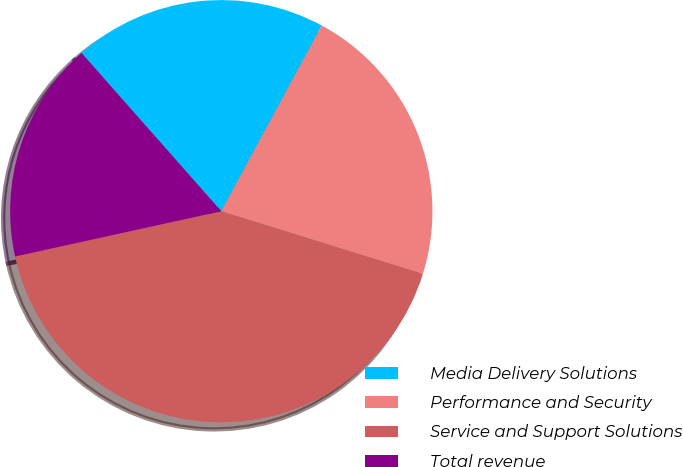Convert chart to OTSL. <chart><loc_0><loc_0><loc_500><loc_500><pie_chart><fcel>Media Delivery Solutions<fcel>Performance and Security<fcel>Service and Support Solutions<fcel>Total revenue<nl><fcel>19.41%<fcel>21.9%<fcel>41.76%<fcel>16.93%<nl></chart> 